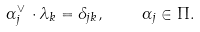<formula> <loc_0><loc_0><loc_500><loc_500>\alpha ^ { \vee } _ { j } \, \cdot \lambda _ { k } = \delta _ { j k } , \quad \alpha _ { j } \in \Pi .</formula> 